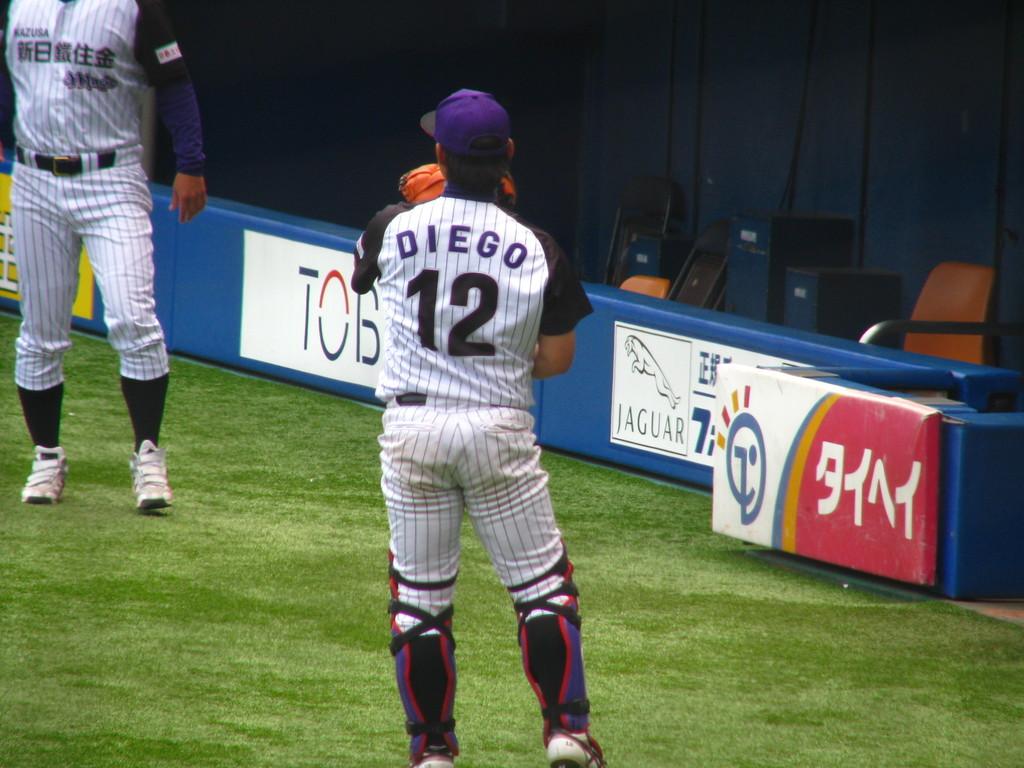What is the name of the player wearing number 12?
Offer a very short reply. Diego. What car company is being advertised?
Give a very brief answer. Jaguar. 